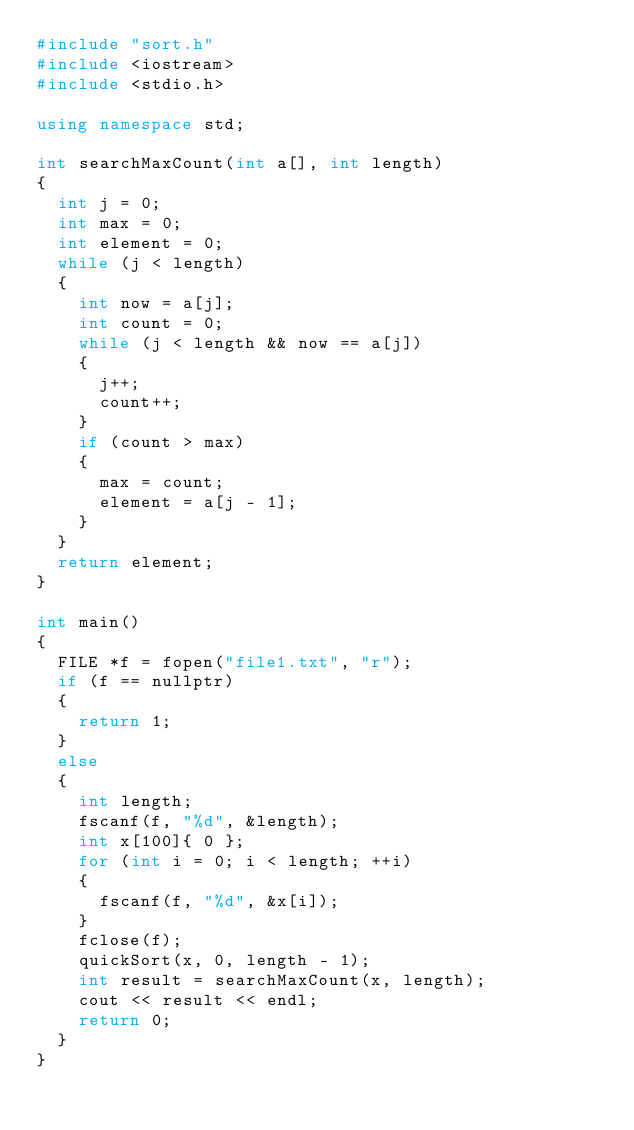Convert code to text. <code><loc_0><loc_0><loc_500><loc_500><_C++_>#include "sort.h"
#include <iostream>
#include <stdio.h>

using namespace std;

int searchMaxCount(int a[], int length)
{
	int j = 0;
	int max = 0;
	int element = 0;
	while (j < length)
	{
		int now = a[j];
		int count = 0;
		while (j < length && now == a[j])
		{
			j++;
			count++;
		}
		if (count > max)
		{
			max = count;
			element = a[j - 1];
		}
	}
	return element;
}

int main()
{
	FILE *f = fopen("file1.txt", "r");
	if (f == nullptr)
	{
		return 1;
	}
	else
	{
		int length;
		fscanf(f, "%d", &length);
		int x[100]{ 0 };
		for (int i = 0; i < length; ++i)
		{
			fscanf(f, "%d", &x[i]);
		}
		fclose(f);
		quickSort(x, 0, length - 1);
		int result = searchMaxCount(x, length);
		cout << result << endl;
		return 0;
	}
}
</code> 